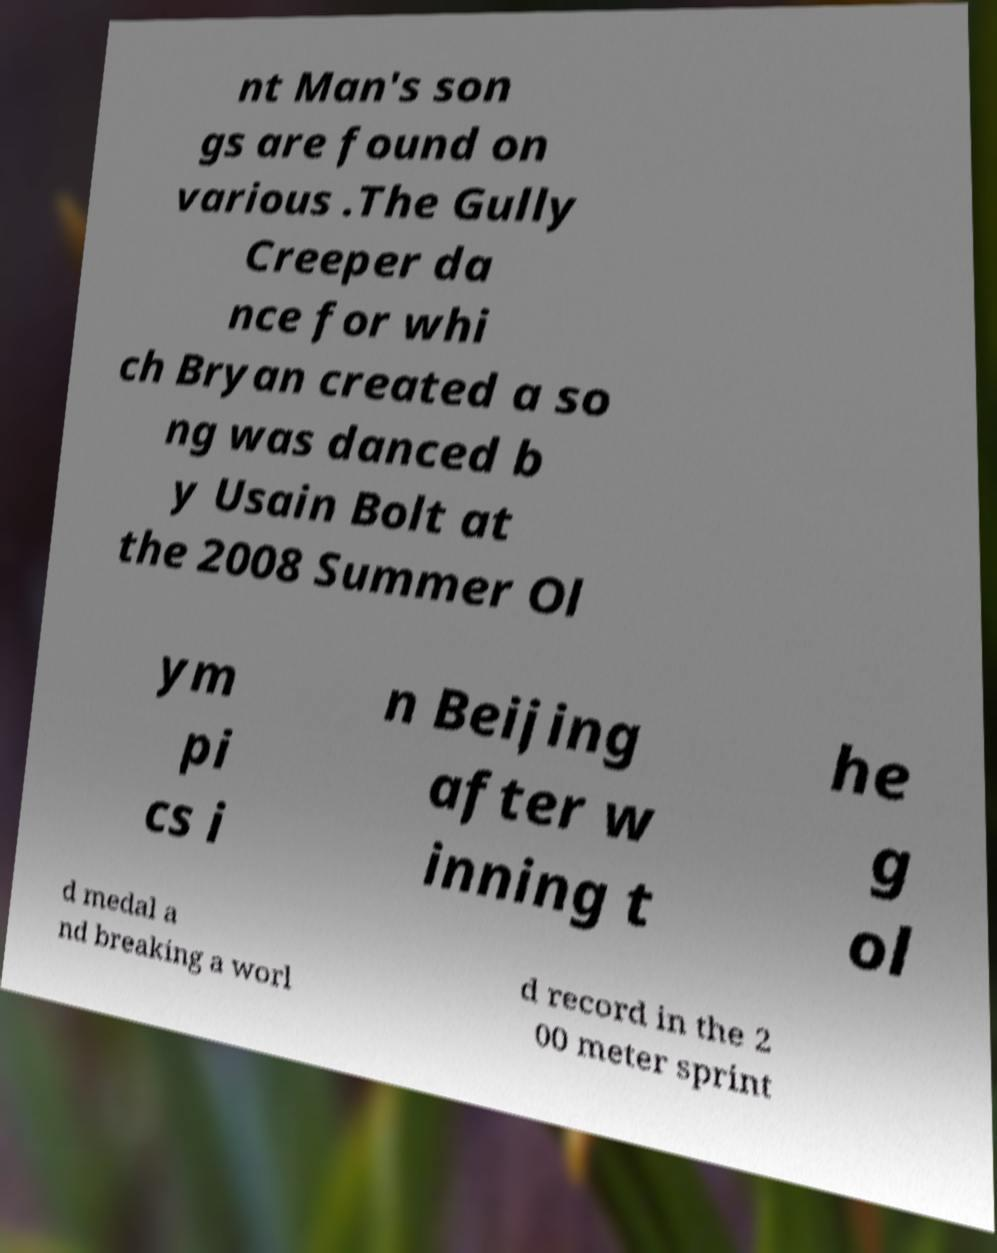I need the written content from this picture converted into text. Can you do that? nt Man's son gs are found on various .The Gully Creeper da nce for whi ch Bryan created a so ng was danced b y Usain Bolt at the 2008 Summer Ol ym pi cs i n Beijing after w inning t he g ol d medal a nd breaking a worl d record in the 2 00 meter sprint 